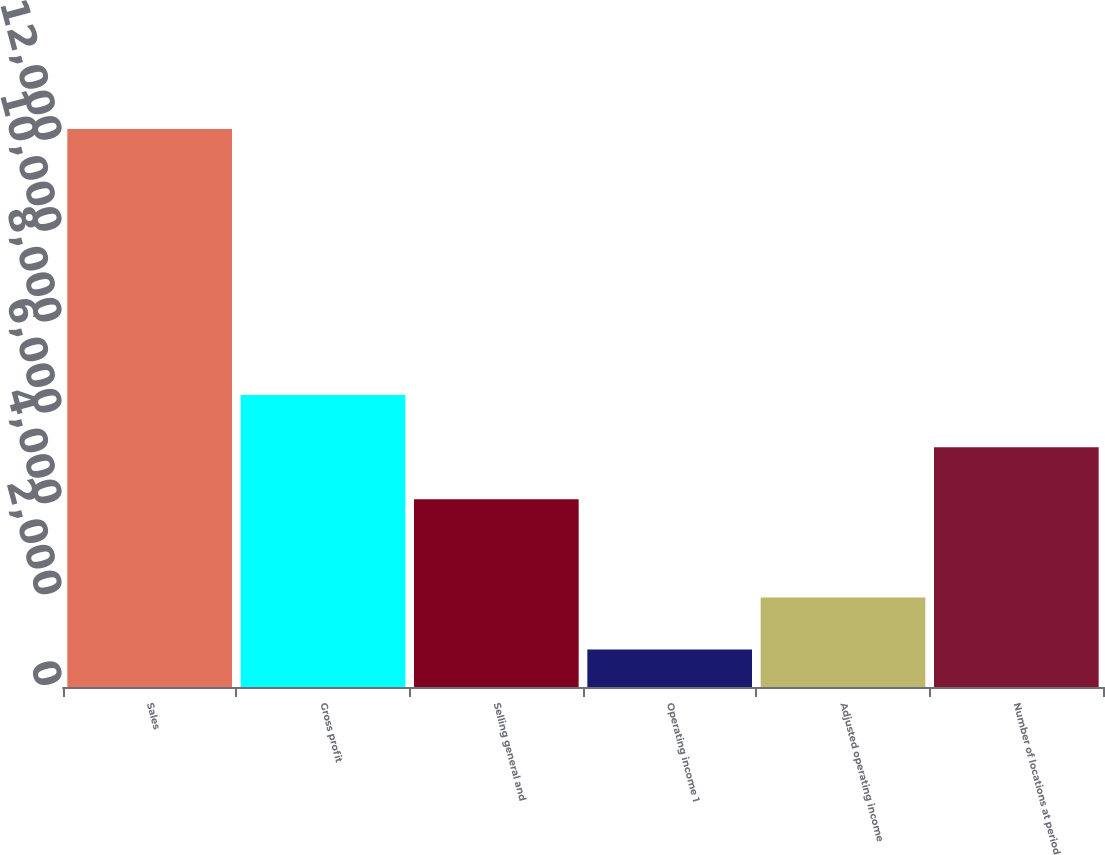<chart> <loc_0><loc_0><loc_500><loc_500><bar_chart><fcel>Sales<fcel>Gross profit<fcel>Selling general and<fcel>Operating income 1<fcel>Adjusted operating income<fcel>Number of locations at period<nl><fcel>12281<fcel>6425.4<fcel>4134<fcel>824<fcel>1969.7<fcel>5279.7<nl></chart> 